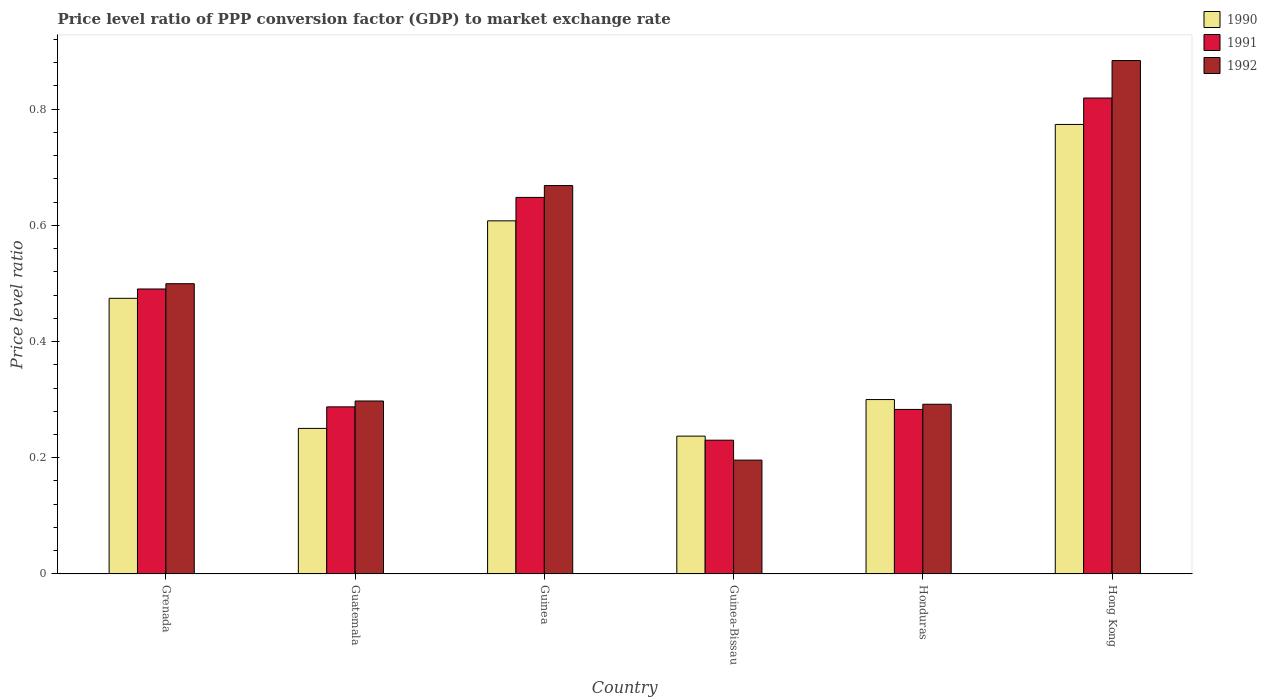How many bars are there on the 1st tick from the right?
Provide a succinct answer. 3. What is the label of the 5th group of bars from the left?
Provide a succinct answer. Honduras. In how many cases, is the number of bars for a given country not equal to the number of legend labels?
Ensure brevity in your answer.  0. What is the price level ratio in 1990 in Guinea-Bissau?
Provide a succinct answer. 0.24. Across all countries, what is the maximum price level ratio in 1992?
Offer a terse response. 0.88. Across all countries, what is the minimum price level ratio in 1992?
Offer a terse response. 0.2. In which country was the price level ratio in 1992 maximum?
Give a very brief answer. Hong Kong. In which country was the price level ratio in 1990 minimum?
Keep it short and to the point. Guinea-Bissau. What is the total price level ratio in 1991 in the graph?
Your answer should be compact. 2.76. What is the difference between the price level ratio in 1991 in Guinea and that in Hong Kong?
Offer a terse response. -0.17. What is the difference between the price level ratio in 1991 in Honduras and the price level ratio in 1990 in Guinea-Bissau?
Your response must be concise. 0.05. What is the average price level ratio in 1990 per country?
Your answer should be compact. 0.44. What is the difference between the price level ratio of/in 1992 and price level ratio of/in 1991 in Hong Kong?
Ensure brevity in your answer.  0.06. In how many countries, is the price level ratio in 1990 greater than 0.8400000000000001?
Make the answer very short. 0. What is the ratio of the price level ratio in 1991 in Guinea to that in Guinea-Bissau?
Make the answer very short. 2.81. Is the price level ratio in 1992 in Grenada less than that in Guinea-Bissau?
Keep it short and to the point. No. Is the difference between the price level ratio in 1992 in Grenada and Guinea-Bissau greater than the difference between the price level ratio in 1991 in Grenada and Guinea-Bissau?
Offer a very short reply. Yes. What is the difference between the highest and the second highest price level ratio in 1990?
Offer a very short reply. 0.17. What is the difference between the highest and the lowest price level ratio in 1990?
Provide a succinct answer. 0.54. In how many countries, is the price level ratio in 1990 greater than the average price level ratio in 1990 taken over all countries?
Your answer should be very brief. 3. Is the sum of the price level ratio in 1991 in Grenada and Guinea-Bissau greater than the maximum price level ratio in 1992 across all countries?
Your answer should be compact. No. What does the 3rd bar from the left in Grenada represents?
Your answer should be very brief. 1992. What does the 3rd bar from the right in Grenada represents?
Give a very brief answer. 1990. Are all the bars in the graph horizontal?
Give a very brief answer. No. How many countries are there in the graph?
Your answer should be very brief. 6. What is the difference between two consecutive major ticks on the Y-axis?
Keep it short and to the point. 0.2. Are the values on the major ticks of Y-axis written in scientific E-notation?
Ensure brevity in your answer.  No. Does the graph contain grids?
Your answer should be compact. No. How are the legend labels stacked?
Your answer should be very brief. Vertical. What is the title of the graph?
Make the answer very short. Price level ratio of PPP conversion factor (GDP) to market exchange rate. What is the label or title of the X-axis?
Your response must be concise. Country. What is the label or title of the Y-axis?
Provide a succinct answer. Price level ratio. What is the Price level ratio of 1990 in Grenada?
Offer a terse response. 0.47. What is the Price level ratio in 1991 in Grenada?
Provide a succinct answer. 0.49. What is the Price level ratio in 1992 in Grenada?
Offer a very short reply. 0.5. What is the Price level ratio in 1990 in Guatemala?
Give a very brief answer. 0.25. What is the Price level ratio in 1991 in Guatemala?
Give a very brief answer. 0.29. What is the Price level ratio in 1992 in Guatemala?
Keep it short and to the point. 0.3. What is the Price level ratio of 1990 in Guinea?
Offer a very short reply. 0.61. What is the Price level ratio in 1991 in Guinea?
Offer a very short reply. 0.65. What is the Price level ratio of 1992 in Guinea?
Your answer should be compact. 0.67. What is the Price level ratio in 1990 in Guinea-Bissau?
Your answer should be very brief. 0.24. What is the Price level ratio of 1991 in Guinea-Bissau?
Your answer should be compact. 0.23. What is the Price level ratio of 1992 in Guinea-Bissau?
Give a very brief answer. 0.2. What is the Price level ratio in 1990 in Honduras?
Your answer should be compact. 0.3. What is the Price level ratio of 1991 in Honduras?
Keep it short and to the point. 0.28. What is the Price level ratio of 1992 in Honduras?
Your response must be concise. 0.29. What is the Price level ratio of 1990 in Hong Kong?
Offer a very short reply. 0.77. What is the Price level ratio of 1991 in Hong Kong?
Provide a short and direct response. 0.82. What is the Price level ratio of 1992 in Hong Kong?
Provide a short and direct response. 0.88. Across all countries, what is the maximum Price level ratio of 1990?
Ensure brevity in your answer.  0.77. Across all countries, what is the maximum Price level ratio of 1991?
Make the answer very short. 0.82. Across all countries, what is the maximum Price level ratio in 1992?
Ensure brevity in your answer.  0.88. Across all countries, what is the minimum Price level ratio of 1990?
Offer a very short reply. 0.24. Across all countries, what is the minimum Price level ratio in 1991?
Make the answer very short. 0.23. Across all countries, what is the minimum Price level ratio of 1992?
Provide a succinct answer. 0.2. What is the total Price level ratio in 1990 in the graph?
Provide a short and direct response. 2.64. What is the total Price level ratio of 1991 in the graph?
Your answer should be very brief. 2.76. What is the total Price level ratio of 1992 in the graph?
Offer a very short reply. 2.84. What is the difference between the Price level ratio in 1990 in Grenada and that in Guatemala?
Your response must be concise. 0.22. What is the difference between the Price level ratio in 1991 in Grenada and that in Guatemala?
Your answer should be compact. 0.2. What is the difference between the Price level ratio of 1992 in Grenada and that in Guatemala?
Offer a terse response. 0.2. What is the difference between the Price level ratio in 1990 in Grenada and that in Guinea?
Your response must be concise. -0.13. What is the difference between the Price level ratio of 1991 in Grenada and that in Guinea?
Give a very brief answer. -0.16. What is the difference between the Price level ratio in 1992 in Grenada and that in Guinea?
Ensure brevity in your answer.  -0.17. What is the difference between the Price level ratio in 1990 in Grenada and that in Guinea-Bissau?
Your answer should be very brief. 0.24. What is the difference between the Price level ratio of 1991 in Grenada and that in Guinea-Bissau?
Offer a terse response. 0.26. What is the difference between the Price level ratio in 1992 in Grenada and that in Guinea-Bissau?
Keep it short and to the point. 0.3. What is the difference between the Price level ratio in 1990 in Grenada and that in Honduras?
Your answer should be very brief. 0.17. What is the difference between the Price level ratio of 1991 in Grenada and that in Honduras?
Provide a succinct answer. 0.21. What is the difference between the Price level ratio in 1992 in Grenada and that in Honduras?
Your answer should be compact. 0.21. What is the difference between the Price level ratio in 1990 in Grenada and that in Hong Kong?
Your response must be concise. -0.3. What is the difference between the Price level ratio in 1991 in Grenada and that in Hong Kong?
Give a very brief answer. -0.33. What is the difference between the Price level ratio in 1992 in Grenada and that in Hong Kong?
Ensure brevity in your answer.  -0.38. What is the difference between the Price level ratio in 1990 in Guatemala and that in Guinea?
Your answer should be very brief. -0.36. What is the difference between the Price level ratio of 1991 in Guatemala and that in Guinea?
Your response must be concise. -0.36. What is the difference between the Price level ratio of 1992 in Guatemala and that in Guinea?
Give a very brief answer. -0.37. What is the difference between the Price level ratio of 1990 in Guatemala and that in Guinea-Bissau?
Provide a short and direct response. 0.01. What is the difference between the Price level ratio of 1991 in Guatemala and that in Guinea-Bissau?
Keep it short and to the point. 0.06. What is the difference between the Price level ratio of 1992 in Guatemala and that in Guinea-Bissau?
Your answer should be very brief. 0.1. What is the difference between the Price level ratio of 1990 in Guatemala and that in Honduras?
Offer a very short reply. -0.05. What is the difference between the Price level ratio of 1991 in Guatemala and that in Honduras?
Your answer should be compact. 0. What is the difference between the Price level ratio of 1992 in Guatemala and that in Honduras?
Your response must be concise. 0.01. What is the difference between the Price level ratio in 1990 in Guatemala and that in Hong Kong?
Make the answer very short. -0.52. What is the difference between the Price level ratio in 1991 in Guatemala and that in Hong Kong?
Make the answer very short. -0.53. What is the difference between the Price level ratio in 1992 in Guatemala and that in Hong Kong?
Offer a very short reply. -0.59. What is the difference between the Price level ratio of 1990 in Guinea and that in Guinea-Bissau?
Offer a very short reply. 0.37. What is the difference between the Price level ratio in 1991 in Guinea and that in Guinea-Bissau?
Your response must be concise. 0.42. What is the difference between the Price level ratio in 1992 in Guinea and that in Guinea-Bissau?
Keep it short and to the point. 0.47. What is the difference between the Price level ratio in 1990 in Guinea and that in Honduras?
Offer a very short reply. 0.31. What is the difference between the Price level ratio in 1991 in Guinea and that in Honduras?
Make the answer very short. 0.36. What is the difference between the Price level ratio of 1992 in Guinea and that in Honduras?
Offer a very short reply. 0.38. What is the difference between the Price level ratio of 1990 in Guinea and that in Hong Kong?
Ensure brevity in your answer.  -0.17. What is the difference between the Price level ratio in 1991 in Guinea and that in Hong Kong?
Keep it short and to the point. -0.17. What is the difference between the Price level ratio in 1992 in Guinea and that in Hong Kong?
Give a very brief answer. -0.22. What is the difference between the Price level ratio in 1990 in Guinea-Bissau and that in Honduras?
Offer a very short reply. -0.06. What is the difference between the Price level ratio of 1991 in Guinea-Bissau and that in Honduras?
Provide a short and direct response. -0.05. What is the difference between the Price level ratio of 1992 in Guinea-Bissau and that in Honduras?
Ensure brevity in your answer.  -0.1. What is the difference between the Price level ratio in 1990 in Guinea-Bissau and that in Hong Kong?
Keep it short and to the point. -0.54. What is the difference between the Price level ratio of 1991 in Guinea-Bissau and that in Hong Kong?
Your answer should be compact. -0.59. What is the difference between the Price level ratio in 1992 in Guinea-Bissau and that in Hong Kong?
Give a very brief answer. -0.69. What is the difference between the Price level ratio in 1990 in Honduras and that in Hong Kong?
Ensure brevity in your answer.  -0.47. What is the difference between the Price level ratio of 1991 in Honduras and that in Hong Kong?
Your answer should be compact. -0.54. What is the difference between the Price level ratio of 1992 in Honduras and that in Hong Kong?
Provide a succinct answer. -0.59. What is the difference between the Price level ratio of 1990 in Grenada and the Price level ratio of 1991 in Guatemala?
Make the answer very short. 0.19. What is the difference between the Price level ratio of 1990 in Grenada and the Price level ratio of 1992 in Guatemala?
Your answer should be compact. 0.18. What is the difference between the Price level ratio of 1991 in Grenada and the Price level ratio of 1992 in Guatemala?
Offer a very short reply. 0.19. What is the difference between the Price level ratio in 1990 in Grenada and the Price level ratio in 1991 in Guinea?
Provide a short and direct response. -0.17. What is the difference between the Price level ratio of 1990 in Grenada and the Price level ratio of 1992 in Guinea?
Your answer should be compact. -0.19. What is the difference between the Price level ratio of 1991 in Grenada and the Price level ratio of 1992 in Guinea?
Give a very brief answer. -0.18. What is the difference between the Price level ratio in 1990 in Grenada and the Price level ratio in 1991 in Guinea-Bissau?
Make the answer very short. 0.24. What is the difference between the Price level ratio of 1990 in Grenada and the Price level ratio of 1992 in Guinea-Bissau?
Provide a short and direct response. 0.28. What is the difference between the Price level ratio of 1991 in Grenada and the Price level ratio of 1992 in Guinea-Bissau?
Offer a very short reply. 0.29. What is the difference between the Price level ratio of 1990 in Grenada and the Price level ratio of 1991 in Honduras?
Make the answer very short. 0.19. What is the difference between the Price level ratio in 1990 in Grenada and the Price level ratio in 1992 in Honduras?
Your answer should be compact. 0.18. What is the difference between the Price level ratio in 1991 in Grenada and the Price level ratio in 1992 in Honduras?
Your answer should be compact. 0.2. What is the difference between the Price level ratio in 1990 in Grenada and the Price level ratio in 1991 in Hong Kong?
Your answer should be very brief. -0.34. What is the difference between the Price level ratio in 1990 in Grenada and the Price level ratio in 1992 in Hong Kong?
Offer a terse response. -0.41. What is the difference between the Price level ratio in 1991 in Grenada and the Price level ratio in 1992 in Hong Kong?
Offer a terse response. -0.39. What is the difference between the Price level ratio in 1990 in Guatemala and the Price level ratio in 1991 in Guinea?
Keep it short and to the point. -0.4. What is the difference between the Price level ratio in 1990 in Guatemala and the Price level ratio in 1992 in Guinea?
Ensure brevity in your answer.  -0.42. What is the difference between the Price level ratio of 1991 in Guatemala and the Price level ratio of 1992 in Guinea?
Your answer should be very brief. -0.38. What is the difference between the Price level ratio of 1990 in Guatemala and the Price level ratio of 1991 in Guinea-Bissau?
Your answer should be very brief. 0.02. What is the difference between the Price level ratio in 1990 in Guatemala and the Price level ratio in 1992 in Guinea-Bissau?
Offer a very short reply. 0.05. What is the difference between the Price level ratio in 1991 in Guatemala and the Price level ratio in 1992 in Guinea-Bissau?
Provide a short and direct response. 0.09. What is the difference between the Price level ratio in 1990 in Guatemala and the Price level ratio in 1991 in Honduras?
Offer a terse response. -0.03. What is the difference between the Price level ratio of 1990 in Guatemala and the Price level ratio of 1992 in Honduras?
Offer a very short reply. -0.04. What is the difference between the Price level ratio of 1991 in Guatemala and the Price level ratio of 1992 in Honduras?
Your answer should be compact. -0. What is the difference between the Price level ratio in 1990 in Guatemala and the Price level ratio in 1991 in Hong Kong?
Give a very brief answer. -0.57. What is the difference between the Price level ratio of 1990 in Guatemala and the Price level ratio of 1992 in Hong Kong?
Provide a short and direct response. -0.63. What is the difference between the Price level ratio in 1991 in Guatemala and the Price level ratio in 1992 in Hong Kong?
Provide a short and direct response. -0.6. What is the difference between the Price level ratio of 1990 in Guinea and the Price level ratio of 1991 in Guinea-Bissau?
Offer a very short reply. 0.38. What is the difference between the Price level ratio in 1990 in Guinea and the Price level ratio in 1992 in Guinea-Bissau?
Ensure brevity in your answer.  0.41. What is the difference between the Price level ratio of 1991 in Guinea and the Price level ratio of 1992 in Guinea-Bissau?
Ensure brevity in your answer.  0.45. What is the difference between the Price level ratio in 1990 in Guinea and the Price level ratio in 1991 in Honduras?
Ensure brevity in your answer.  0.32. What is the difference between the Price level ratio in 1990 in Guinea and the Price level ratio in 1992 in Honduras?
Give a very brief answer. 0.32. What is the difference between the Price level ratio in 1991 in Guinea and the Price level ratio in 1992 in Honduras?
Provide a succinct answer. 0.36. What is the difference between the Price level ratio in 1990 in Guinea and the Price level ratio in 1991 in Hong Kong?
Ensure brevity in your answer.  -0.21. What is the difference between the Price level ratio of 1990 in Guinea and the Price level ratio of 1992 in Hong Kong?
Make the answer very short. -0.28. What is the difference between the Price level ratio in 1991 in Guinea and the Price level ratio in 1992 in Hong Kong?
Ensure brevity in your answer.  -0.24. What is the difference between the Price level ratio in 1990 in Guinea-Bissau and the Price level ratio in 1991 in Honduras?
Make the answer very short. -0.05. What is the difference between the Price level ratio in 1990 in Guinea-Bissau and the Price level ratio in 1992 in Honduras?
Ensure brevity in your answer.  -0.05. What is the difference between the Price level ratio in 1991 in Guinea-Bissau and the Price level ratio in 1992 in Honduras?
Ensure brevity in your answer.  -0.06. What is the difference between the Price level ratio of 1990 in Guinea-Bissau and the Price level ratio of 1991 in Hong Kong?
Your answer should be compact. -0.58. What is the difference between the Price level ratio of 1990 in Guinea-Bissau and the Price level ratio of 1992 in Hong Kong?
Give a very brief answer. -0.65. What is the difference between the Price level ratio of 1991 in Guinea-Bissau and the Price level ratio of 1992 in Hong Kong?
Make the answer very short. -0.65. What is the difference between the Price level ratio of 1990 in Honduras and the Price level ratio of 1991 in Hong Kong?
Your response must be concise. -0.52. What is the difference between the Price level ratio in 1990 in Honduras and the Price level ratio in 1992 in Hong Kong?
Your answer should be compact. -0.58. What is the difference between the Price level ratio in 1991 in Honduras and the Price level ratio in 1992 in Hong Kong?
Offer a very short reply. -0.6. What is the average Price level ratio of 1990 per country?
Ensure brevity in your answer.  0.44. What is the average Price level ratio in 1991 per country?
Provide a succinct answer. 0.46. What is the average Price level ratio in 1992 per country?
Give a very brief answer. 0.47. What is the difference between the Price level ratio in 1990 and Price level ratio in 1991 in Grenada?
Your response must be concise. -0.02. What is the difference between the Price level ratio in 1990 and Price level ratio in 1992 in Grenada?
Your response must be concise. -0.03. What is the difference between the Price level ratio of 1991 and Price level ratio of 1992 in Grenada?
Your answer should be compact. -0.01. What is the difference between the Price level ratio of 1990 and Price level ratio of 1991 in Guatemala?
Provide a short and direct response. -0.04. What is the difference between the Price level ratio of 1990 and Price level ratio of 1992 in Guatemala?
Make the answer very short. -0.05. What is the difference between the Price level ratio in 1991 and Price level ratio in 1992 in Guatemala?
Provide a succinct answer. -0.01. What is the difference between the Price level ratio of 1990 and Price level ratio of 1991 in Guinea?
Your answer should be compact. -0.04. What is the difference between the Price level ratio in 1990 and Price level ratio in 1992 in Guinea?
Ensure brevity in your answer.  -0.06. What is the difference between the Price level ratio of 1991 and Price level ratio of 1992 in Guinea?
Keep it short and to the point. -0.02. What is the difference between the Price level ratio of 1990 and Price level ratio of 1991 in Guinea-Bissau?
Keep it short and to the point. 0.01. What is the difference between the Price level ratio of 1990 and Price level ratio of 1992 in Guinea-Bissau?
Give a very brief answer. 0.04. What is the difference between the Price level ratio of 1991 and Price level ratio of 1992 in Guinea-Bissau?
Your response must be concise. 0.03. What is the difference between the Price level ratio of 1990 and Price level ratio of 1991 in Honduras?
Offer a terse response. 0.02. What is the difference between the Price level ratio of 1990 and Price level ratio of 1992 in Honduras?
Your answer should be very brief. 0.01. What is the difference between the Price level ratio in 1991 and Price level ratio in 1992 in Honduras?
Your answer should be compact. -0.01. What is the difference between the Price level ratio of 1990 and Price level ratio of 1991 in Hong Kong?
Your answer should be compact. -0.05. What is the difference between the Price level ratio in 1990 and Price level ratio in 1992 in Hong Kong?
Provide a succinct answer. -0.11. What is the difference between the Price level ratio of 1991 and Price level ratio of 1992 in Hong Kong?
Provide a succinct answer. -0.06. What is the ratio of the Price level ratio in 1990 in Grenada to that in Guatemala?
Offer a very short reply. 1.89. What is the ratio of the Price level ratio of 1991 in Grenada to that in Guatemala?
Your response must be concise. 1.71. What is the ratio of the Price level ratio of 1992 in Grenada to that in Guatemala?
Your response must be concise. 1.68. What is the ratio of the Price level ratio in 1990 in Grenada to that in Guinea?
Ensure brevity in your answer.  0.78. What is the ratio of the Price level ratio of 1991 in Grenada to that in Guinea?
Make the answer very short. 0.76. What is the ratio of the Price level ratio of 1992 in Grenada to that in Guinea?
Your response must be concise. 0.75. What is the ratio of the Price level ratio in 1990 in Grenada to that in Guinea-Bissau?
Your answer should be compact. 2. What is the ratio of the Price level ratio of 1991 in Grenada to that in Guinea-Bissau?
Offer a terse response. 2.13. What is the ratio of the Price level ratio in 1992 in Grenada to that in Guinea-Bissau?
Keep it short and to the point. 2.55. What is the ratio of the Price level ratio of 1990 in Grenada to that in Honduras?
Your response must be concise. 1.58. What is the ratio of the Price level ratio of 1991 in Grenada to that in Honduras?
Give a very brief answer. 1.73. What is the ratio of the Price level ratio in 1992 in Grenada to that in Honduras?
Your answer should be compact. 1.71. What is the ratio of the Price level ratio of 1990 in Grenada to that in Hong Kong?
Your response must be concise. 0.61. What is the ratio of the Price level ratio of 1991 in Grenada to that in Hong Kong?
Give a very brief answer. 0.6. What is the ratio of the Price level ratio of 1992 in Grenada to that in Hong Kong?
Offer a terse response. 0.57. What is the ratio of the Price level ratio of 1990 in Guatemala to that in Guinea?
Offer a terse response. 0.41. What is the ratio of the Price level ratio of 1991 in Guatemala to that in Guinea?
Provide a short and direct response. 0.44. What is the ratio of the Price level ratio in 1992 in Guatemala to that in Guinea?
Make the answer very short. 0.45. What is the ratio of the Price level ratio in 1990 in Guatemala to that in Guinea-Bissau?
Keep it short and to the point. 1.06. What is the ratio of the Price level ratio in 1991 in Guatemala to that in Guinea-Bissau?
Your answer should be compact. 1.25. What is the ratio of the Price level ratio in 1992 in Guatemala to that in Guinea-Bissau?
Your response must be concise. 1.52. What is the ratio of the Price level ratio in 1990 in Guatemala to that in Honduras?
Your response must be concise. 0.83. What is the ratio of the Price level ratio of 1991 in Guatemala to that in Honduras?
Provide a short and direct response. 1.02. What is the ratio of the Price level ratio in 1992 in Guatemala to that in Honduras?
Keep it short and to the point. 1.02. What is the ratio of the Price level ratio in 1990 in Guatemala to that in Hong Kong?
Offer a terse response. 0.32. What is the ratio of the Price level ratio in 1991 in Guatemala to that in Hong Kong?
Give a very brief answer. 0.35. What is the ratio of the Price level ratio in 1992 in Guatemala to that in Hong Kong?
Offer a very short reply. 0.34. What is the ratio of the Price level ratio of 1990 in Guinea to that in Guinea-Bissau?
Provide a short and direct response. 2.56. What is the ratio of the Price level ratio in 1991 in Guinea to that in Guinea-Bissau?
Make the answer very short. 2.81. What is the ratio of the Price level ratio in 1992 in Guinea to that in Guinea-Bissau?
Make the answer very short. 3.41. What is the ratio of the Price level ratio of 1990 in Guinea to that in Honduras?
Ensure brevity in your answer.  2.02. What is the ratio of the Price level ratio of 1991 in Guinea to that in Honduras?
Provide a succinct answer. 2.29. What is the ratio of the Price level ratio of 1992 in Guinea to that in Honduras?
Give a very brief answer. 2.29. What is the ratio of the Price level ratio in 1990 in Guinea to that in Hong Kong?
Keep it short and to the point. 0.79. What is the ratio of the Price level ratio in 1991 in Guinea to that in Hong Kong?
Make the answer very short. 0.79. What is the ratio of the Price level ratio of 1992 in Guinea to that in Hong Kong?
Keep it short and to the point. 0.76. What is the ratio of the Price level ratio of 1990 in Guinea-Bissau to that in Honduras?
Provide a short and direct response. 0.79. What is the ratio of the Price level ratio of 1991 in Guinea-Bissau to that in Honduras?
Ensure brevity in your answer.  0.81. What is the ratio of the Price level ratio in 1992 in Guinea-Bissau to that in Honduras?
Provide a short and direct response. 0.67. What is the ratio of the Price level ratio in 1990 in Guinea-Bissau to that in Hong Kong?
Your answer should be compact. 0.31. What is the ratio of the Price level ratio in 1991 in Guinea-Bissau to that in Hong Kong?
Give a very brief answer. 0.28. What is the ratio of the Price level ratio in 1992 in Guinea-Bissau to that in Hong Kong?
Your answer should be very brief. 0.22. What is the ratio of the Price level ratio of 1990 in Honduras to that in Hong Kong?
Your answer should be compact. 0.39. What is the ratio of the Price level ratio in 1991 in Honduras to that in Hong Kong?
Make the answer very short. 0.35. What is the ratio of the Price level ratio of 1992 in Honduras to that in Hong Kong?
Your response must be concise. 0.33. What is the difference between the highest and the second highest Price level ratio in 1990?
Give a very brief answer. 0.17. What is the difference between the highest and the second highest Price level ratio of 1991?
Your answer should be very brief. 0.17. What is the difference between the highest and the second highest Price level ratio of 1992?
Give a very brief answer. 0.22. What is the difference between the highest and the lowest Price level ratio of 1990?
Give a very brief answer. 0.54. What is the difference between the highest and the lowest Price level ratio in 1991?
Provide a succinct answer. 0.59. What is the difference between the highest and the lowest Price level ratio of 1992?
Provide a succinct answer. 0.69. 